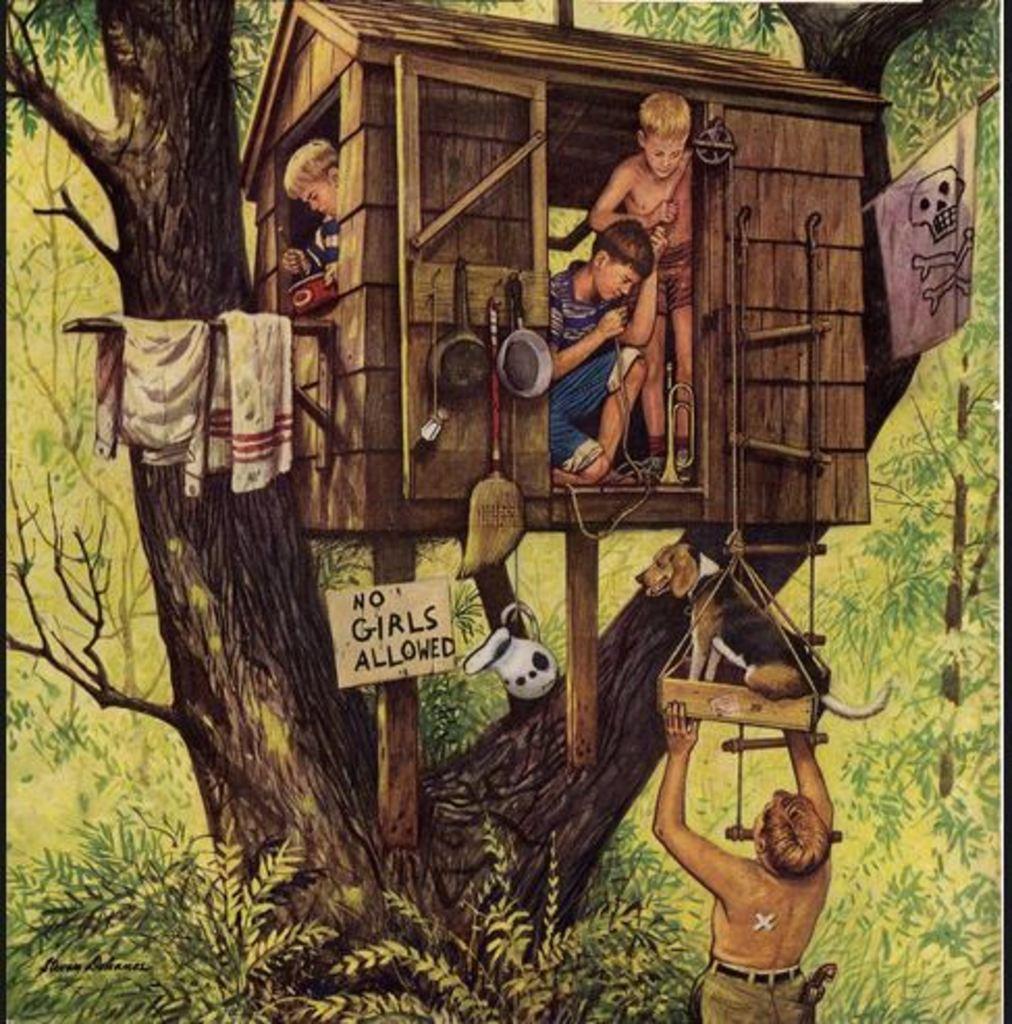Could you give a brief overview of what you see in this image? In this picture we can see the painting of boys in the hut. To the hut there is a flag and other things. Behind the hut there are trees. 